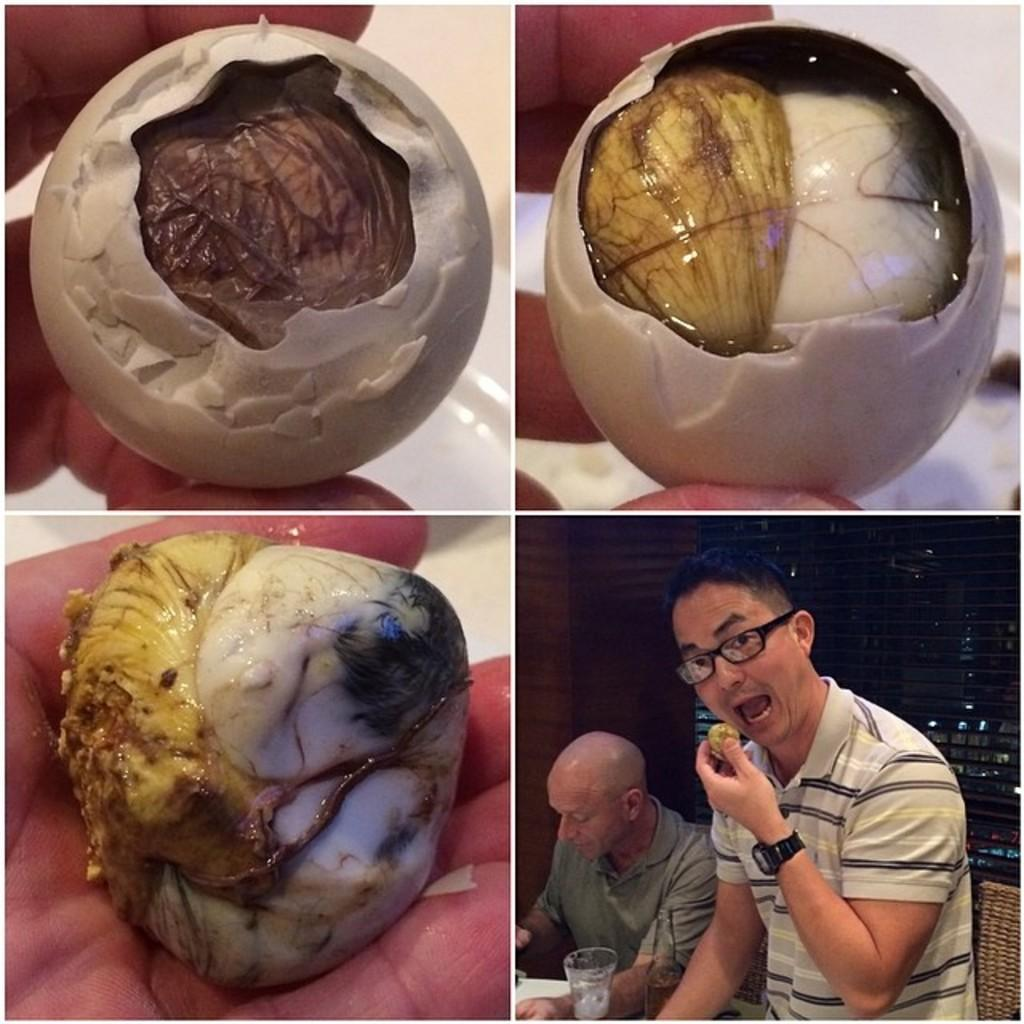What type of picture is in the image? The image contains a collage picture. How many people are in the collage? There are two people in the collage. What is one person doing in the collage? One person is holding food. What can be seen besides the people in the collage? There is a glass and a pillar in the collage, as well as other objects. What type of furniture can be seen in the image? There is no furniture present in the image; it contains a collage with people, a glass, a pillar, and other objects. How much coal is visible in the image? There is no coal present in the image. 